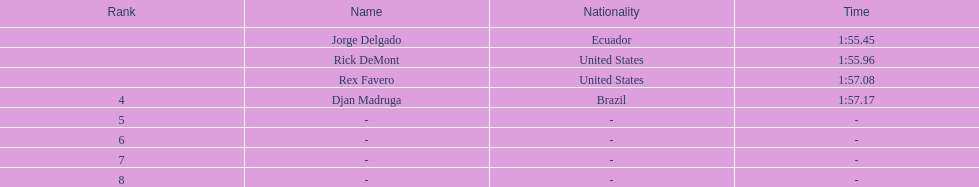Who was the last finisher from the us? Rex Favero. 